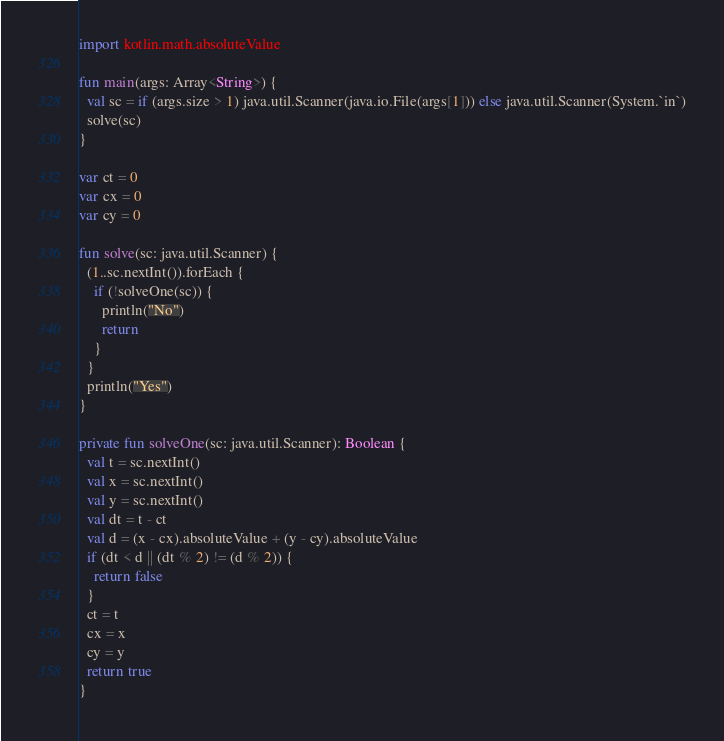Convert code to text. <code><loc_0><loc_0><loc_500><loc_500><_Kotlin_>import kotlin.math.absoluteValue

fun main(args: Array<String>) {
  val sc = if (args.size > 1) java.util.Scanner(java.io.File(args[1])) else java.util.Scanner(System.`in`)
  solve(sc)
}

var ct = 0
var cx = 0
var cy = 0

fun solve(sc: java.util.Scanner) {
  (1..sc.nextInt()).forEach {
    if (!solveOne(sc)) {
      println("No")
      return
    }
  }
  println("Yes")
}

private fun solveOne(sc: java.util.Scanner): Boolean {
  val t = sc.nextInt()
  val x = sc.nextInt()
  val y = sc.nextInt()
  val dt = t - ct
  val d = (x - cx).absoluteValue + (y - cy).absoluteValue
  if (dt < d || (dt % 2) != (d % 2)) {
    return false
  }
  ct = t
  cx = x
  cy = y
  return true
}
</code> 